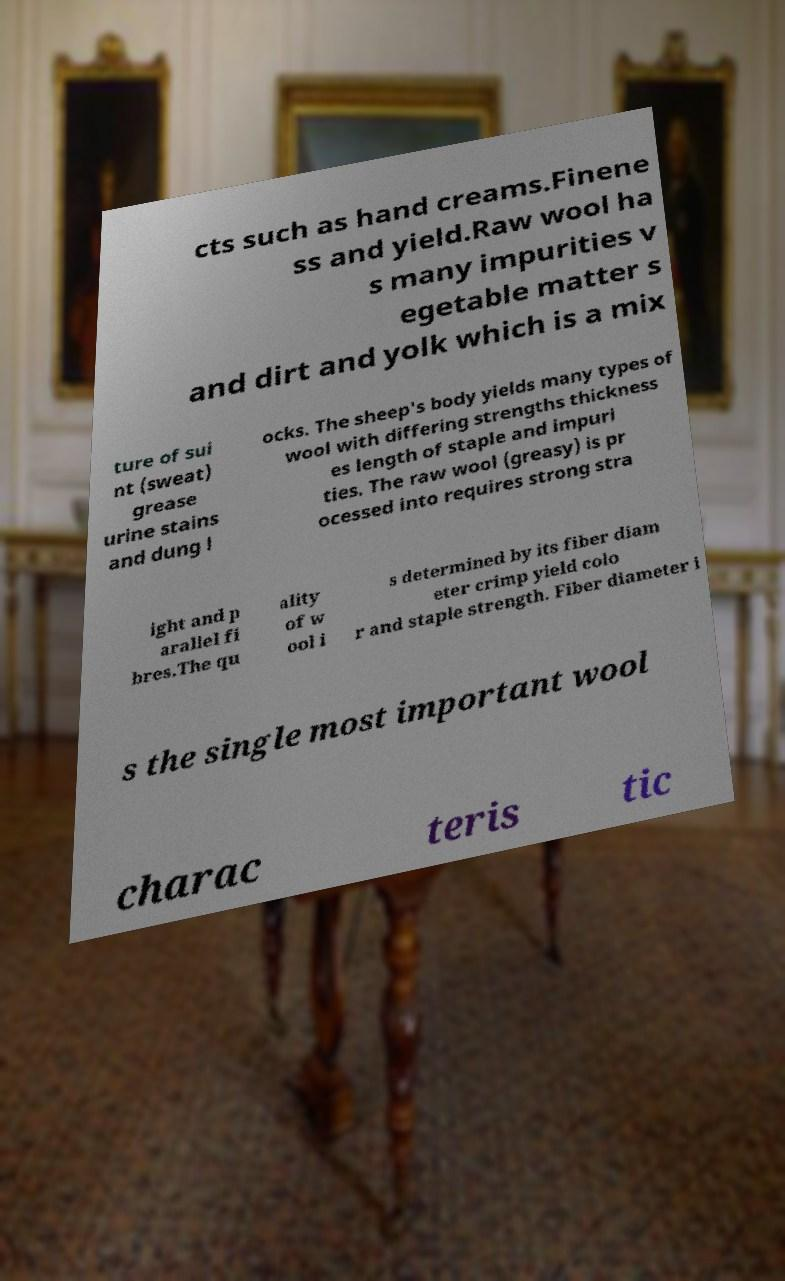For documentation purposes, I need the text within this image transcribed. Could you provide that? cts such as hand creams.Finene ss and yield.Raw wool ha s many impurities v egetable matter s and dirt and yolk which is a mix ture of sui nt (sweat) grease urine stains and dung l ocks. The sheep's body yields many types of wool with differing strengths thickness es length of staple and impuri ties. The raw wool (greasy) is pr ocessed into requires strong stra ight and p arallel fi bres.The qu ality of w ool i s determined by its fiber diam eter crimp yield colo r and staple strength. Fiber diameter i s the single most important wool charac teris tic 